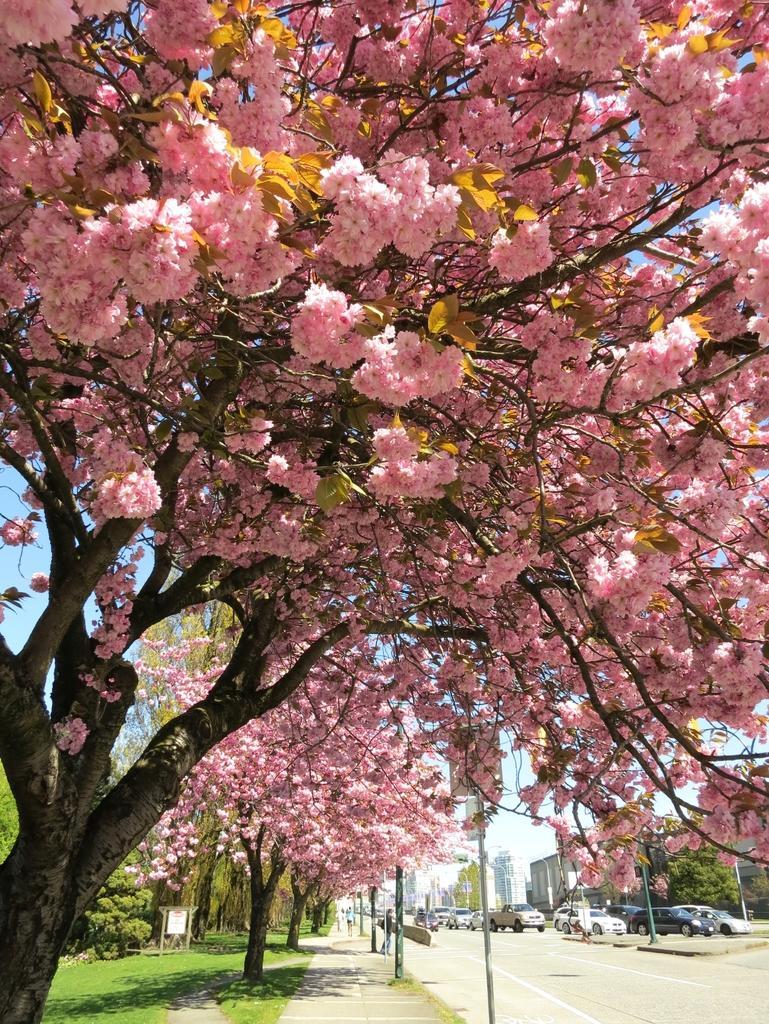How would you summarize this image in a sentence or two? In this picture we can see there are trees, grass and poles. On the right side of the trees, there are vehicles, road and buildings. Behind the trees, there is the sky. 